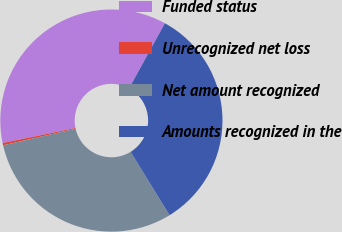Convert chart to OTSL. <chart><loc_0><loc_0><loc_500><loc_500><pie_chart><fcel>Funded status<fcel>Unrecognized net loss<fcel>Net amount recognized<fcel>Amounts recognized in the<nl><fcel>36.24%<fcel>0.33%<fcel>30.2%<fcel>33.22%<nl></chart> 